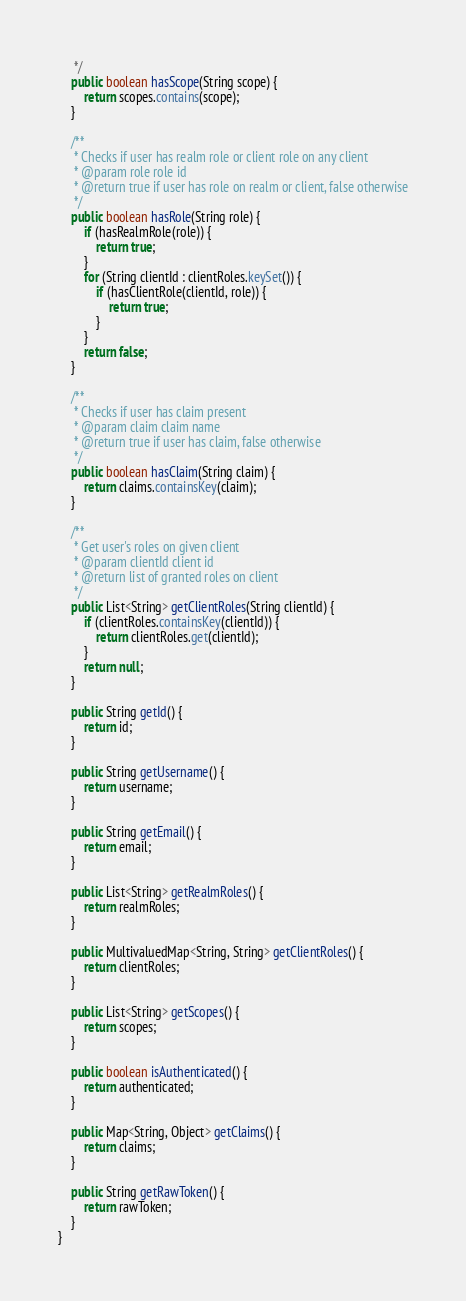<code> <loc_0><loc_0><loc_500><loc_500><_Java_>     */
    public boolean hasScope(String scope) {
        return scopes.contains(scope);
    }
    
    /**
     * Checks if user has realm role or client role on any client
     * @param role role id
     * @return true if user has role on realm or client, false otherwise
     */
    public boolean hasRole(String role) {
        if (hasRealmRole(role)) {
            return true;
        }
        for (String clientId : clientRoles.keySet()) {
            if (hasClientRole(clientId, role)) {
                return true;
            }
        }
        return false;
    }
    
    /**
     * Checks if user has claim present
     * @param claim claim name
     * @return true if user has claim, false otherwise
     */
    public boolean hasClaim(String claim) {
        return claims.containsKey(claim);
    }
    
    /**
     * Get user's roles on given client
     * @param clientId client id
     * @return list of granted roles on client
     */
    public List<String> getClientRoles(String clientId) {
        if (clientRoles.containsKey(clientId)) {
            return clientRoles.get(clientId);
        }
        return null;
    }
    
    public String getId() {
        return id;
    }
    
    public String getUsername() {
        return username;
    }
    
    public String getEmail() {
        return email;
    }
    
    public List<String> getRealmRoles() {
        return realmRoles;
    }
    
    public MultivaluedMap<String, String> getClientRoles() {
        return clientRoles;
    }
    
    public List<String> getScopes() {
        return scopes;
    }
    
    public boolean isAuthenticated() {
        return authenticated;
    }
    
    public Map<String, Object> getClaims() {
        return claims;
    }
    
    public String getRawToken() {
        return rawToken;
    }
}
</code> 